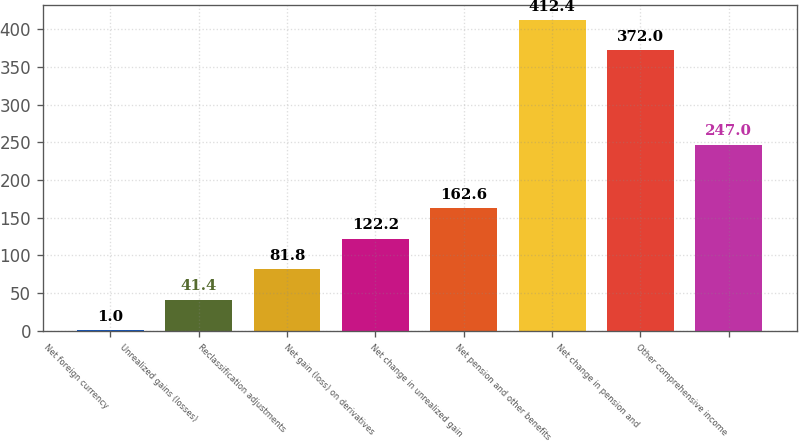<chart> <loc_0><loc_0><loc_500><loc_500><bar_chart><fcel>Net foreign currency<fcel>Unrealized gains (losses)<fcel>Reclassification adjustments<fcel>Net gain (loss) on derivatives<fcel>Net change in unrealized gain<fcel>Net pension and other benefits<fcel>Net change in pension and<fcel>Other comprehensive income<nl><fcel>1<fcel>41.4<fcel>81.8<fcel>122.2<fcel>162.6<fcel>412.4<fcel>372<fcel>247<nl></chart> 